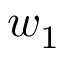<formula> <loc_0><loc_0><loc_500><loc_500>w _ { 1 }</formula> 